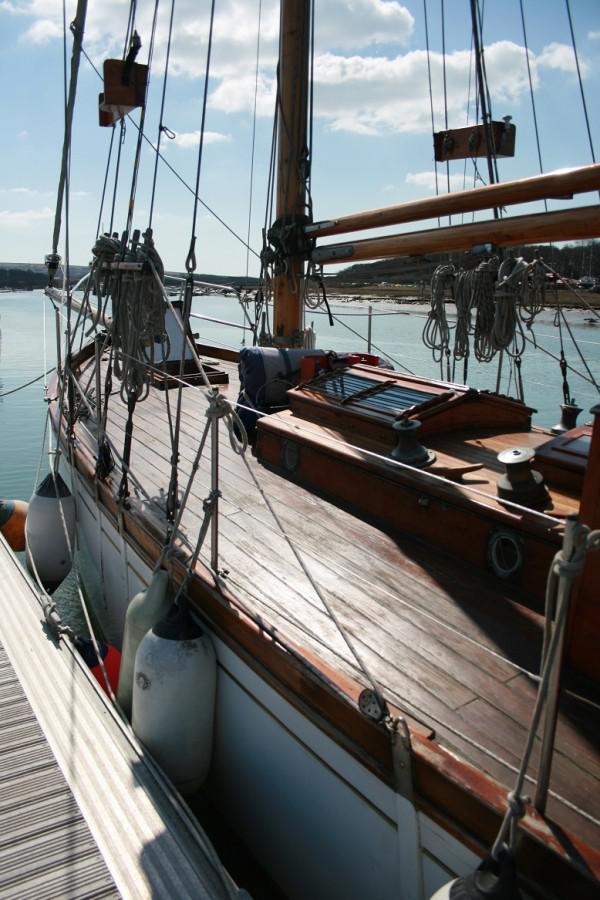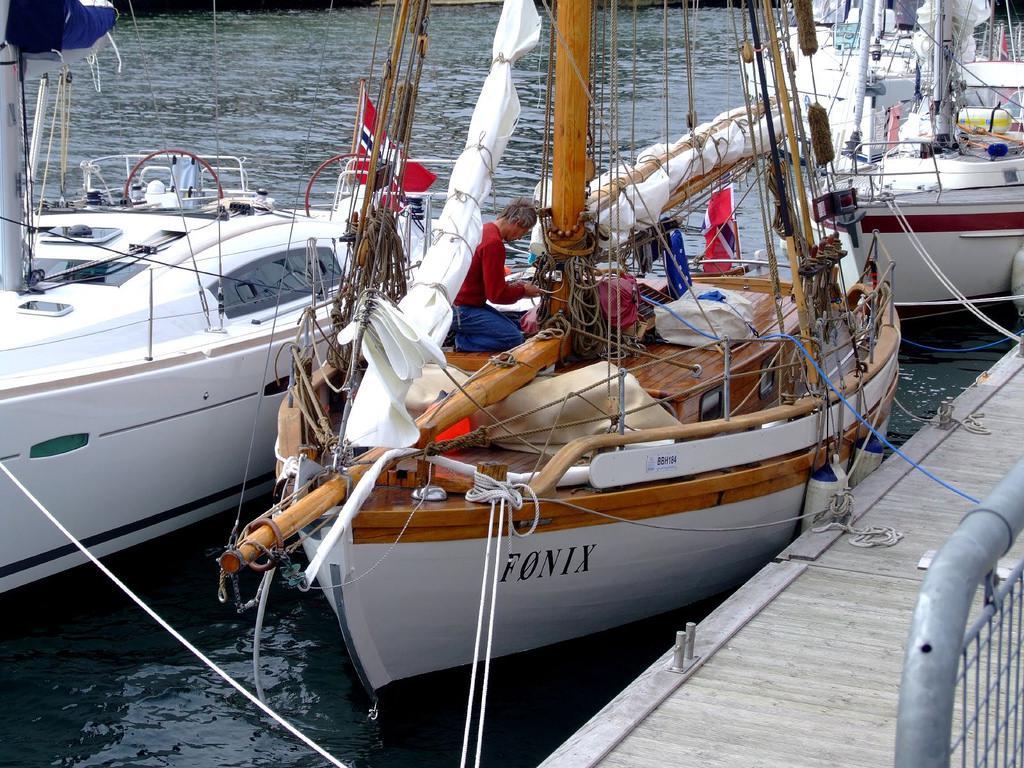The first image is the image on the left, the second image is the image on the right. Analyze the images presented: Is the assertion "Some of the boats have multiple flags attached to them and none are American Flags." valid? Answer yes or no. Yes. 